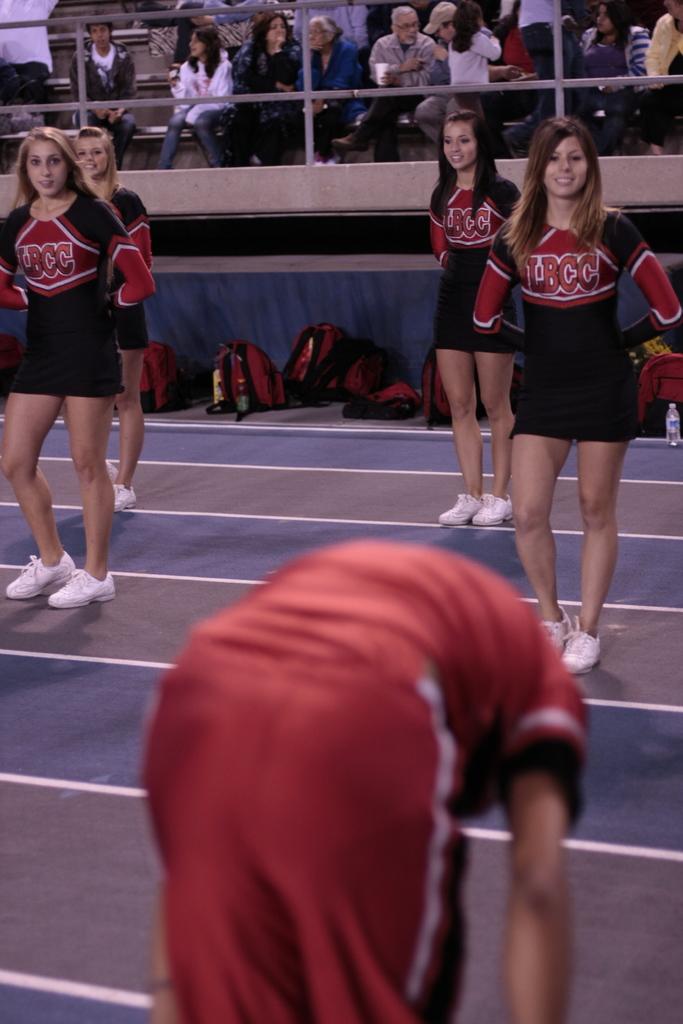What is written on the cheerleaders' uniforms?
Your answer should be very brief. Lbcc. 